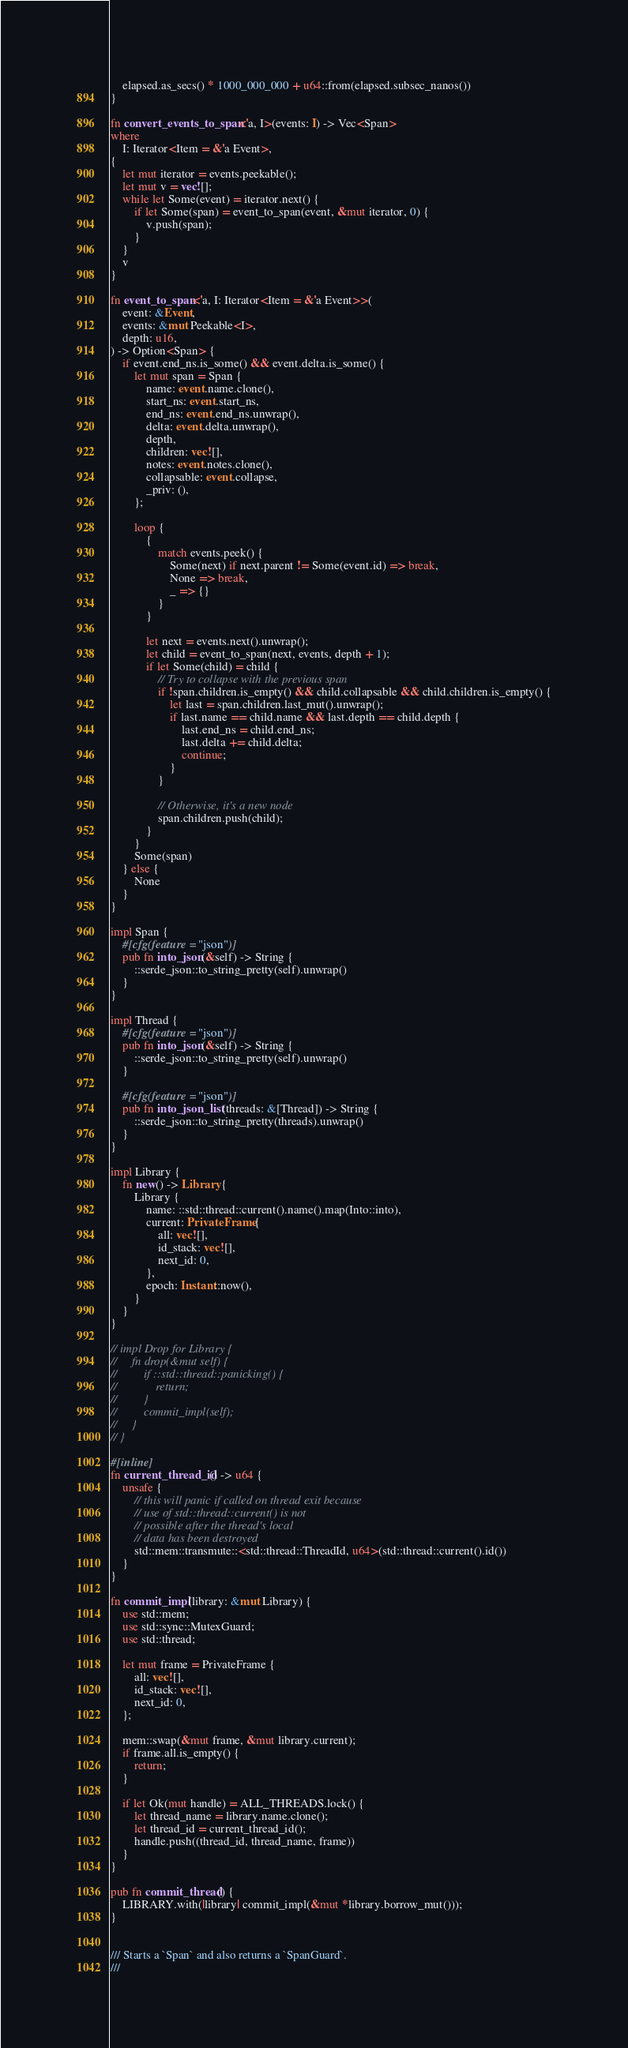Convert code to text. <code><loc_0><loc_0><loc_500><loc_500><_Rust_>    elapsed.as_secs() * 1000_000_000 + u64::from(elapsed.subsec_nanos())
}

fn convert_events_to_span<'a, I>(events: I) -> Vec<Span>
where
    I: Iterator<Item = &'a Event>,
{
    let mut iterator = events.peekable();
    let mut v = vec![];
    while let Some(event) = iterator.next() {
        if let Some(span) = event_to_span(event, &mut iterator, 0) {
            v.push(span);
        }
    }
    v
}

fn event_to_span<'a, I: Iterator<Item = &'a Event>>(
    event: &Event,
    events: &mut Peekable<I>,
    depth: u16,
) -> Option<Span> {
    if event.end_ns.is_some() && event.delta.is_some() {
        let mut span = Span {
            name: event.name.clone(),
            start_ns: event.start_ns,
            end_ns: event.end_ns.unwrap(),
            delta: event.delta.unwrap(),
            depth,
            children: vec![],
            notes: event.notes.clone(),
            collapsable: event.collapse,
            _priv: (),
        };

        loop {
            {
                match events.peek() {
                    Some(next) if next.parent != Some(event.id) => break,
                    None => break,
                    _ => {}
                }
            }

            let next = events.next().unwrap();
            let child = event_to_span(next, events, depth + 1);
            if let Some(child) = child {
                // Try to collapse with the previous span
                if !span.children.is_empty() && child.collapsable && child.children.is_empty() {
                    let last = span.children.last_mut().unwrap();
                    if last.name == child.name && last.depth == child.depth {
                        last.end_ns = child.end_ns;
                        last.delta += child.delta;
                        continue;
                    }
                }

                // Otherwise, it's a new node
                span.children.push(child);
            }
        }
        Some(span)
    } else {
        None
    }
}

impl Span {
    #[cfg(feature = "json")]
    pub fn into_json(&self) -> String {
        ::serde_json::to_string_pretty(self).unwrap()
    }
}

impl Thread {
    #[cfg(feature = "json")]
    pub fn into_json(&self) -> String {
        ::serde_json::to_string_pretty(self).unwrap()
    }

    #[cfg(feature = "json")]
    pub fn into_json_list(threads: &[Thread]) -> String {
        ::serde_json::to_string_pretty(threads).unwrap()
    }
}

impl Library {
    fn new() -> Library {
        Library {
            name: ::std::thread::current().name().map(Into::into),
            current: PrivateFrame {
                all: vec![],
                id_stack: vec![],
                next_id: 0,
            },
            epoch: Instant::now(),
        }
    }
}

// impl Drop for Library {
//     fn drop(&mut self) {
//         if ::std::thread::panicking() {
//             return;
//         }
//         commit_impl(self);
//     }
// }

#[inline]
fn current_thread_id() -> u64 {
    unsafe {
        // this will panic if called on thread exit because
        // use of std::thread::current() is not
        // possible after the thread's local
        // data has been destroyed
        std::mem::transmute::<std::thread::ThreadId, u64>(std::thread::current().id())
    }
}

fn commit_impl(library: &mut Library) {
    use std::mem;
    use std::sync::MutexGuard;
    use std::thread;

    let mut frame = PrivateFrame {
        all: vec![],
        id_stack: vec![],
        next_id: 0,
    };

    mem::swap(&mut frame, &mut library.current);
    if frame.all.is_empty() {
        return;
    }

    if let Ok(mut handle) = ALL_THREADS.lock() {
        let thread_name = library.name.clone();
        let thread_id = current_thread_id();
        handle.push((thread_id, thread_name, frame))
    }
}

pub fn commit_thread() {
    LIBRARY.with(|library| commit_impl(&mut *library.borrow_mut()));
}


/// Starts a `Span` and also returns a `SpanGuard`.
///</code> 